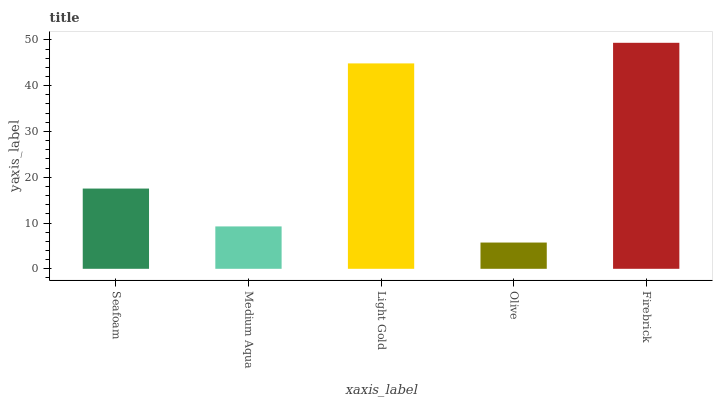Is Medium Aqua the minimum?
Answer yes or no. No. Is Medium Aqua the maximum?
Answer yes or no. No. Is Seafoam greater than Medium Aqua?
Answer yes or no. Yes. Is Medium Aqua less than Seafoam?
Answer yes or no. Yes. Is Medium Aqua greater than Seafoam?
Answer yes or no. No. Is Seafoam less than Medium Aqua?
Answer yes or no. No. Is Seafoam the high median?
Answer yes or no. Yes. Is Seafoam the low median?
Answer yes or no. Yes. Is Medium Aqua the high median?
Answer yes or no. No. Is Light Gold the low median?
Answer yes or no. No. 